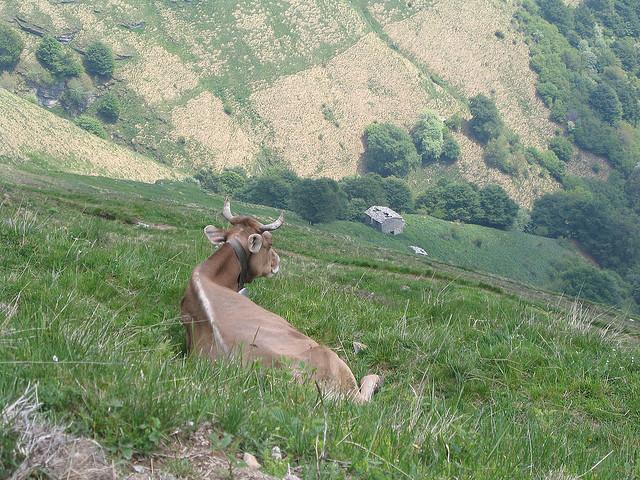Does this animal have horns?
Keep it brief. Yes. Is the cow looking at its home in the distance?
Short answer required. Yes. Is this animal on a hill?
Answer briefly. Yes. 